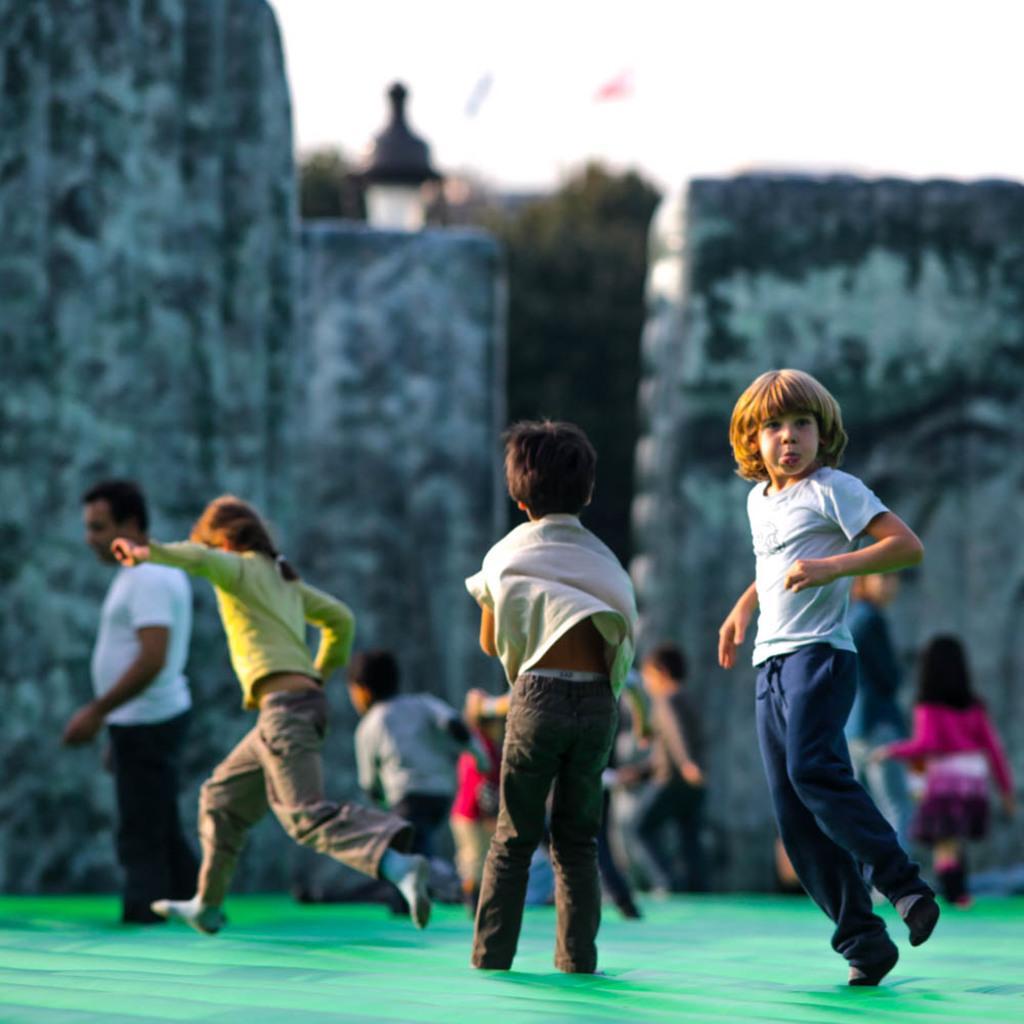Describe this image in one or two sentences. In this picture I can see group of people. There are walls, trees, and in the background there is the sky. 